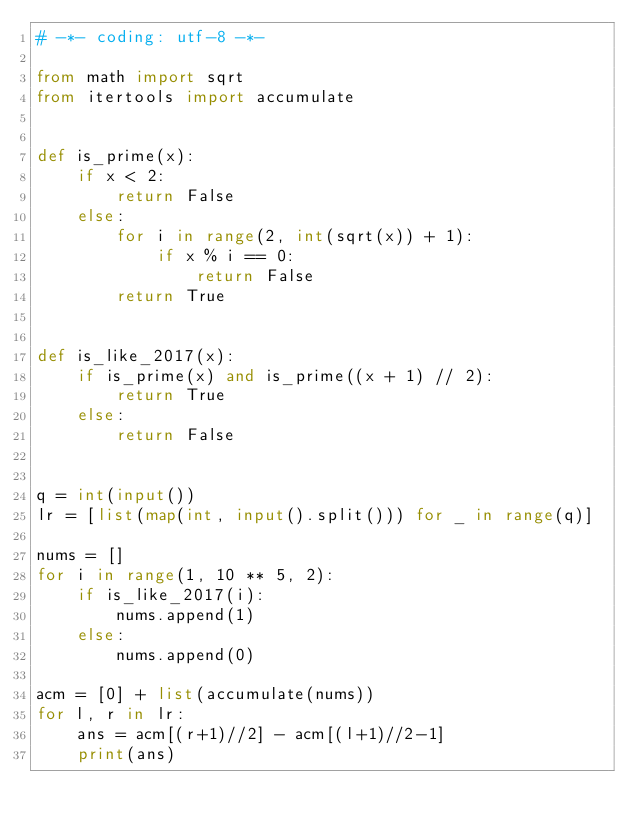<code> <loc_0><loc_0><loc_500><loc_500><_Python_># -*- coding: utf-8 -*-

from math import sqrt
from itertools import accumulate


def is_prime(x):
    if x < 2:
        return False
    else:
        for i in range(2, int(sqrt(x)) + 1):
            if x % i == 0:
                return False
        return True


def is_like_2017(x):
    if is_prime(x) and is_prime((x + 1) // 2):
        return True
    else:
        return False


q = int(input())
lr = [list(map(int, input().split())) for _ in range(q)]

nums = []
for i in range(1, 10 ** 5, 2):
    if is_like_2017(i):
        nums.append(1)
    else:
        nums.append(0)

acm = [0] + list(accumulate(nums))
for l, r in lr:
    ans = acm[(r+1)//2] - acm[(l+1)//2-1]
    print(ans)

</code> 